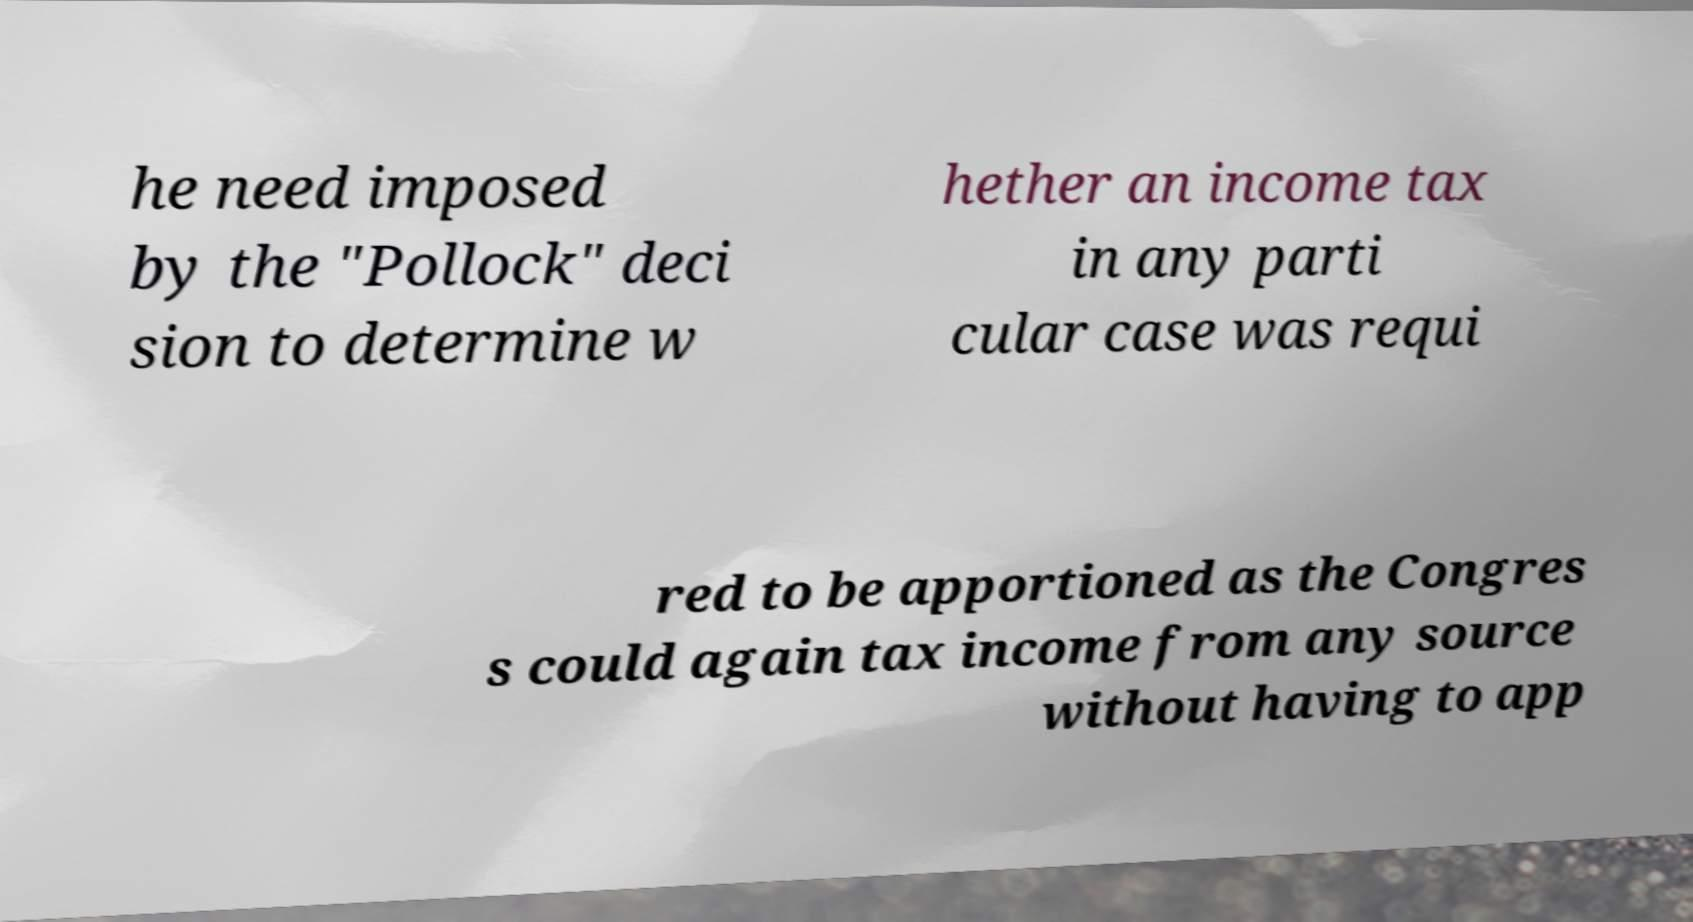I need the written content from this picture converted into text. Can you do that? he need imposed by the "Pollock" deci sion to determine w hether an income tax in any parti cular case was requi red to be apportioned as the Congres s could again tax income from any source without having to app 